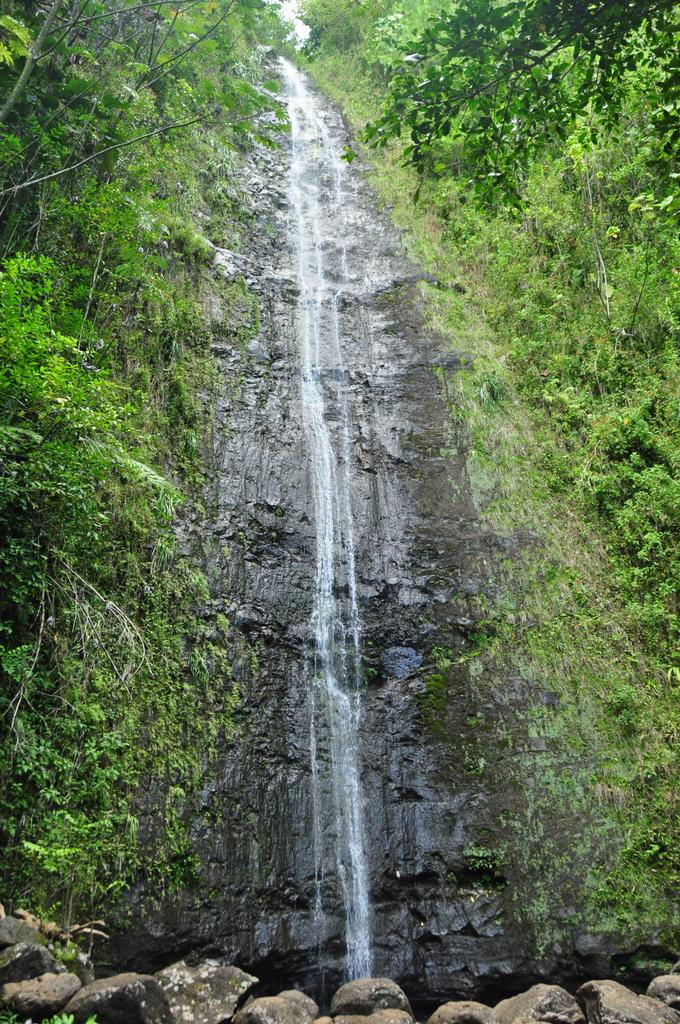What natural feature is present in the image? There is a waterfall in the image. What type of geological formation can be seen in the image? There are rocks in the image. What type of vegetation is present in the image? There are trees and plants in the image. What type of music can be heard coming from the waterfall in the image? There is no indication in the image that music is coming from the waterfall, as waterfalls do not produce music. Is there any fire visible in the image? There is no fire present in the image. Can you see any cows in the image? There is no cow present in the image. 